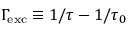<formula> <loc_0><loc_0><loc_500><loc_500>\Gamma \, _ { e x c } \equiv 1 / \tau - 1 / \tau _ { 0 }</formula> 